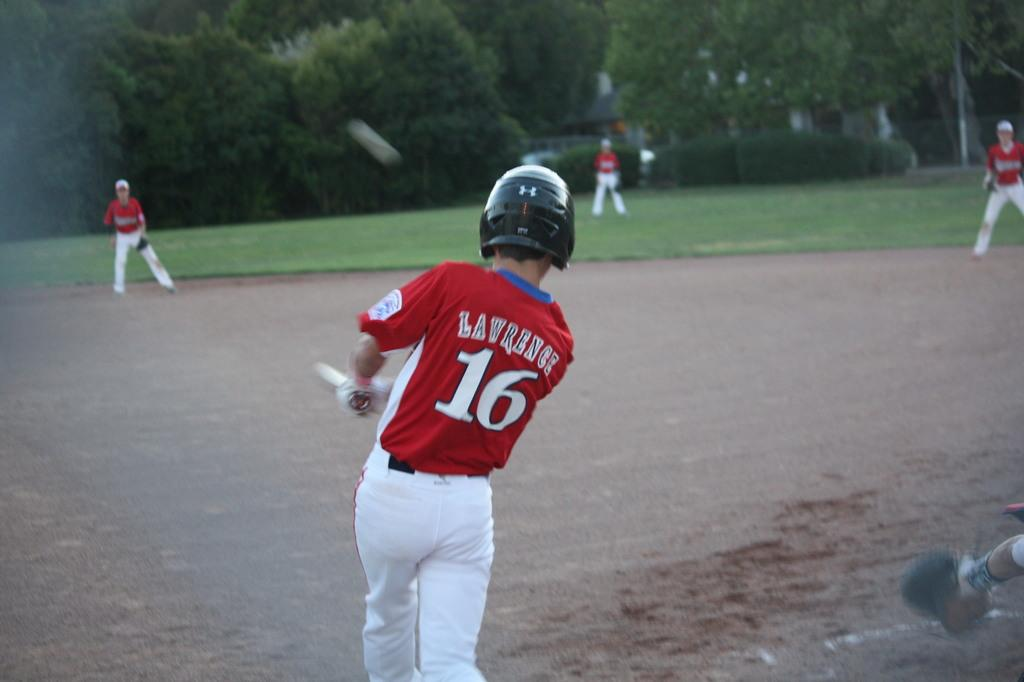<image>
Relay a brief, clear account of the picture shown. A batter has the number 16 on the back of his jersey. 